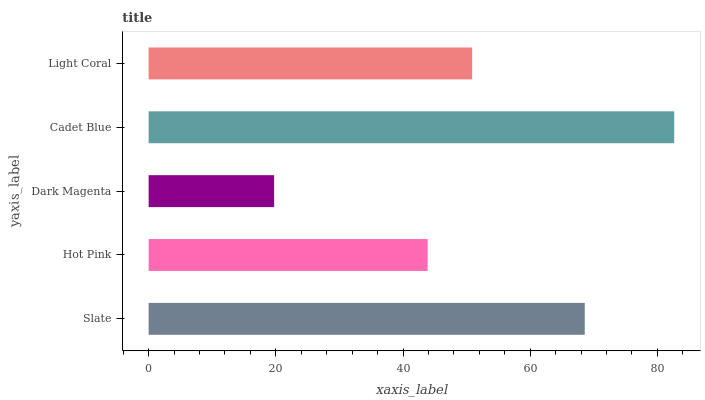Is Dark Magenta the minimum?
Answer yes or no. Yes. Is Cadet Blue the maximum?
Answer yes or no. Yes. Is Hot Pink the minimum?
Answer yes or no. No. Is Hot Pink the maximum?
Answer yes or no. No. Is Slate greater than Hot Pink?
Answer yes or no. Yes. Is Hot Pink less than Slate?
Answer yes or no. Yes. Is Hot Pink greater than Slate?
Answer yes or no. No. Is Slate less than Hot Pink?
Answer yes or no. No. Is Light Coral the high median?
Answer yes or no. Yes. Is Light Coral the low median?
Answer yes or no. Yes. Is Hot Pink the high median?
Answer yes or no. No. Is Dark Magenta the low median?
Answer yes or no. No. 